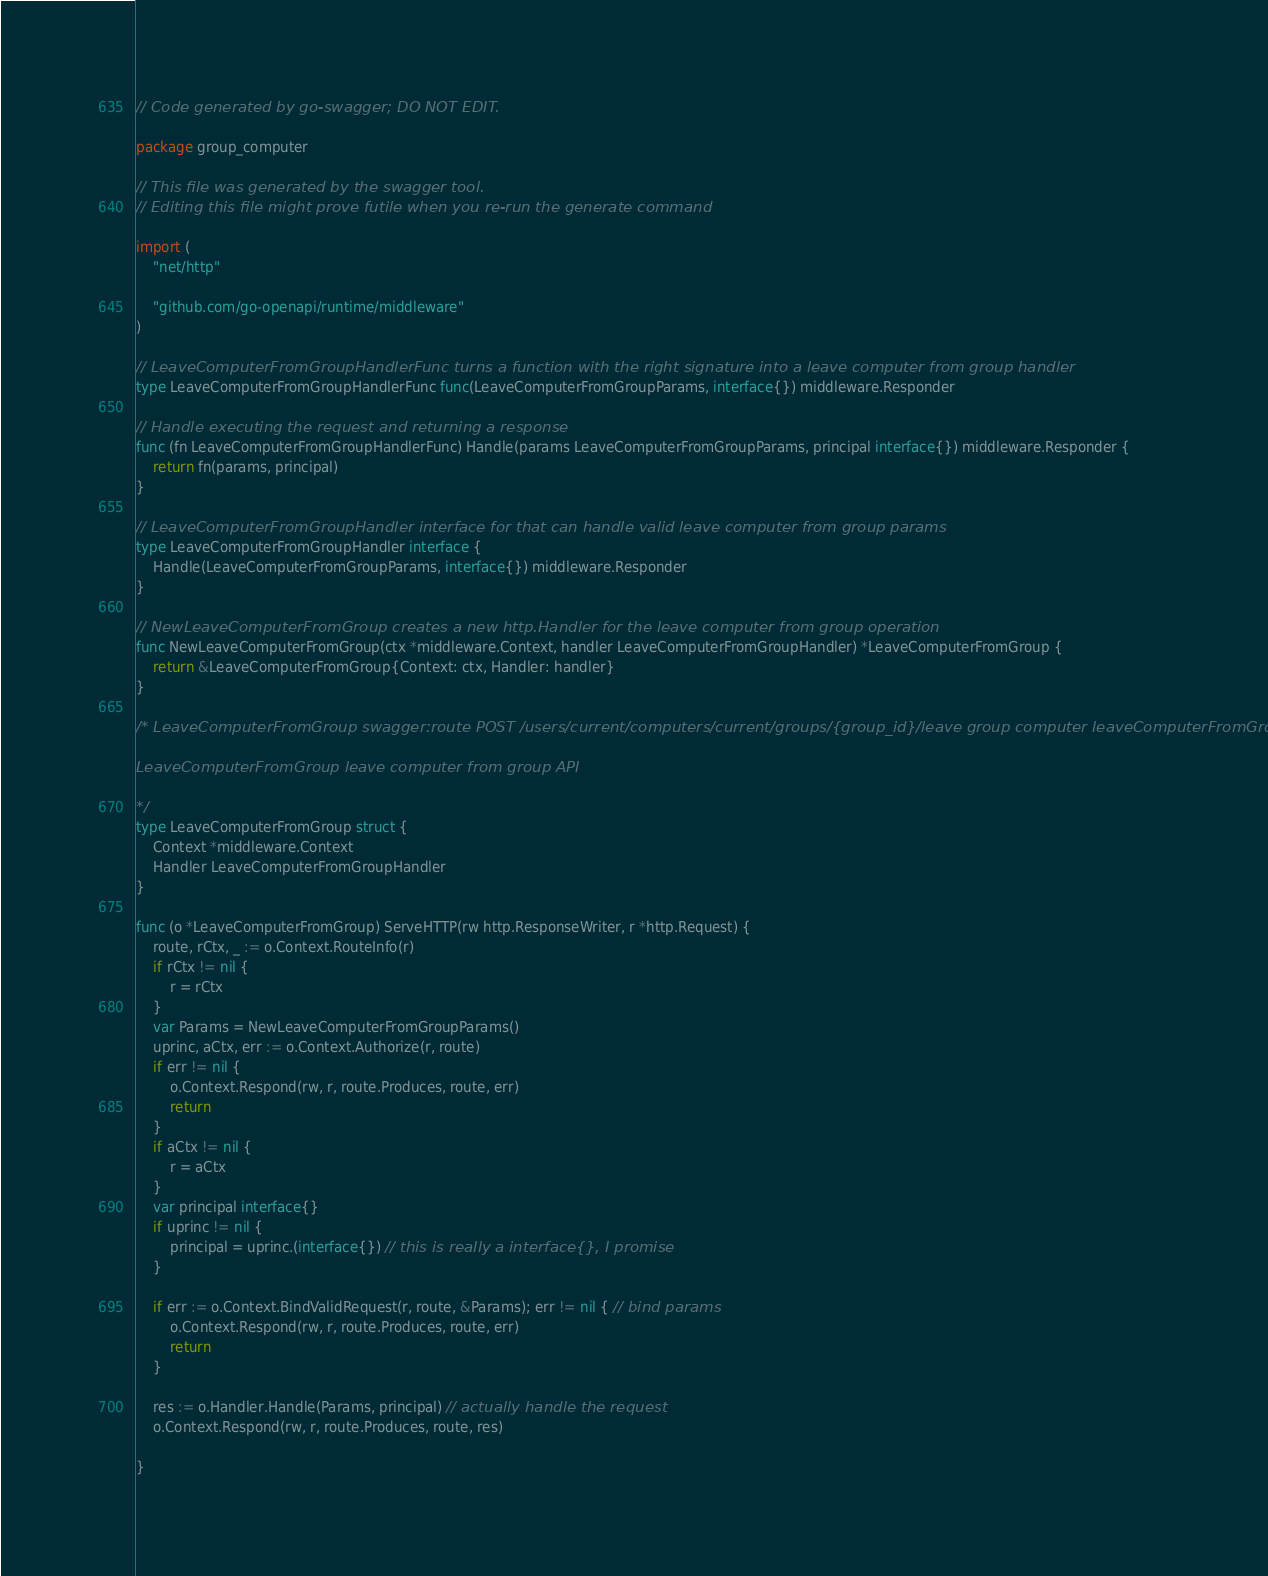Convert code to text. <code><loc_0><loc_0><loc_500><loc_500><_Go_>// Code generated by go-swagger; DO NOT EDIT.

package group_computer

// This file was generated by the swagger tool.
// Editing this file might prove futile when you re-run the generate command

import (
	"net/http"

	"github.com/go-openapi/runtime/middleware"
)

// LeaveComputerFromGroupHandlerFunc turns a function with the right signature into a leave computer from group handler
type LeaveComputerFromGroupHandlerFunc func(LeaveComputerFromGroupParams, interface{}) middleware.Responder

// Handle executing the request and returning a response
func (fn LeaveComputerFromGroupHandlerFunc) Handle(params LeaveComputerFromGroupParams, principal interface{}) middleware.Responder {
	return fn(params, principal)
}

// LeaveComputerFromGroupHandler interface for that can handle valid leave computer from group params
type LeaveComputerFromGroupHandler interface {
	Handle(LeaveComputerFromGroupParams, interface{}) middleware.Responder
}

// NewLeaveComputerFromGroup creates a new http.Handler for the leave computer from group operation
func NewLeaveComputerFromGroup(ctx *middleware.Context, handler LeaveComputerFromGroupHandler) *LeaveComputerFromGroup {
	return &LeaveComputerFromGroup{Context: ctx, Handler: handler}
}

/* LeaveComputerFromGroup swagger:route POST /users/current/computers/current/groups/{group_id}/leave group computer leaveComputerFromGroup

LeaveComputerFromGroup leave computer from group API

*/
type LeaveComputerFromGroup struct {
	Context *middleware.Context
	Handler LeaveComputerFromGroupHandler
}

func (o *LeaveComputerFromGroup) ServeHTTP(rw http.ResponseWriter, r *http.Request) {
	route, rCtx, _ := o.Context.RouteInfo(r)
	if rCtx != nil {
		r = rCtx
	}
	var Params = NewLeaveComputerFromGroupParams()
	uprinc, aCtx, err := o.Context.Authorize(r, route)
	if err != nil {
		o.Context.Respond(rw, r, route.Produces, route, err)
		return
	}
	if aCtx != nil {
		r = aCtx
	}
	var principal interface{}
	if uprinc != nil {
		principal = uprinc.(interface{}) // this is really a interface{}, I promise
	}

	if err := o.Context.BindValidRequest(r, route, &Params); err != nil { // bind params
		o.Context.Respond(rw, r, route.Produces, route, err)
		return
	}

	res := o.Handler.Handle(Params, principal) // actually handle the request
	o.Context.Respond(rw, r, route.Produces, route, res)

}
</code> 